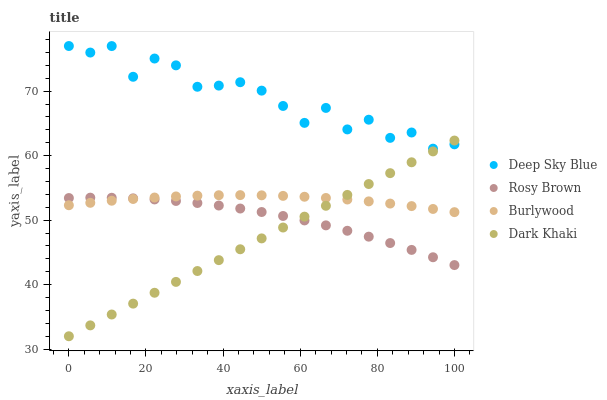Does Dark Khaki have the minimum area under the curve?
Answer yes or no. Yes. Does Deep Sky Blue have the maximum area under the curve?
Answer yes or no. Yes. Does Rosy Brown have the minimum area under the curve?
Answer yes or no. No. Does Rosy Brown have the maximum area under the curve?
Answer yes or no. No. Is Dark Khaki the smoothest?
Answer yes or no. Yes. Is Deep Sky Blue the roughest?
Answer yes or no. Yes. Is Rosy Brown the smoothest?
Answer yes or no. No. Is Rosy Brown the roughest?
Answer yes or no. No. Does Dark Khaki have the lowest value?
Answer yes or no. Yes. Does Rosy Brown have the lowest value?
Answer yes or no. No. Does Deep Sky Blue have the highest value?
Answer yes or no. Yes. Does Dark Khaki have the highest value?
Answer yes or no. No. Is Rosy Brown less than Deep Sky Blue?
Answer yes or no. Yes. Is Deep Sky Blue greater than Rosy Brown?
Answer yes or no. Yes. Does Dark Khaki intersect Deep Sky Blue?
Answer yes or no. Yes. Is Dark Khaki less than Deep Sky Blue?
Answer yes or no. No. Is Dark Khaki greater than Deep Sky Blue?
Answer yes or no. No. Does Rosy Brown intersect Deep Sky Blue?
Answer yes or no. No. 